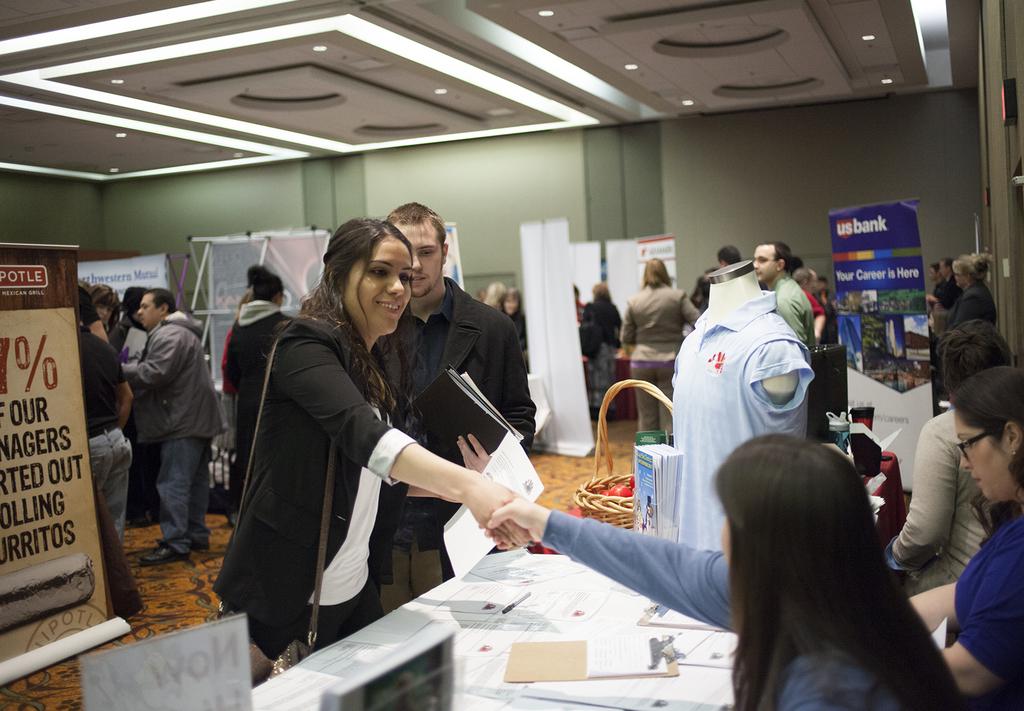What do the posters in the room advertise?
Offer a terse response. Chipotle. What bank is advertised on the blue sign on the right?
Ensure brevity in your answer.  Us bank. 